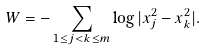Convert formula to latex. <formula><loc_0><loc_0><loc_500><loc_500>W = - \sum _ { 1 \leq j < k \leq m } \log | x _ { j } ^ { 2 } - x _ { k } ^ { 2 } | .</formula> 